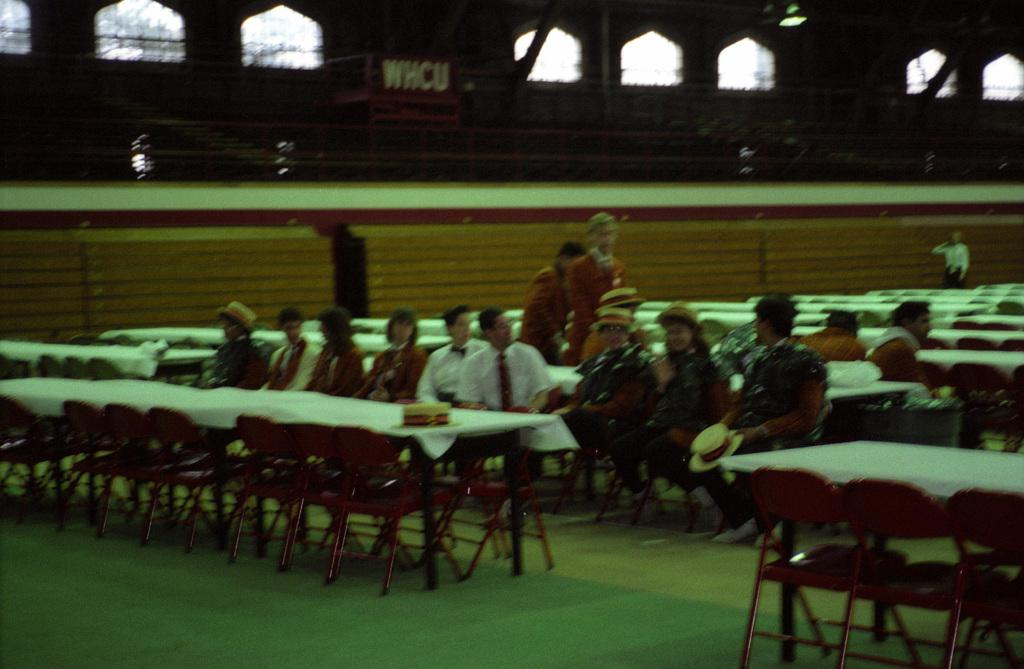What are the people in the image doing? The people in the image are sitting on chairs. How many chairs are occupied in the image? Most of the chairs are unoccupied in the image. What type of queen is present in the image? There is no queen present in the image; it features people sitting on chairs. What type of stove can be seen in the image? There is no stove present in the image. 